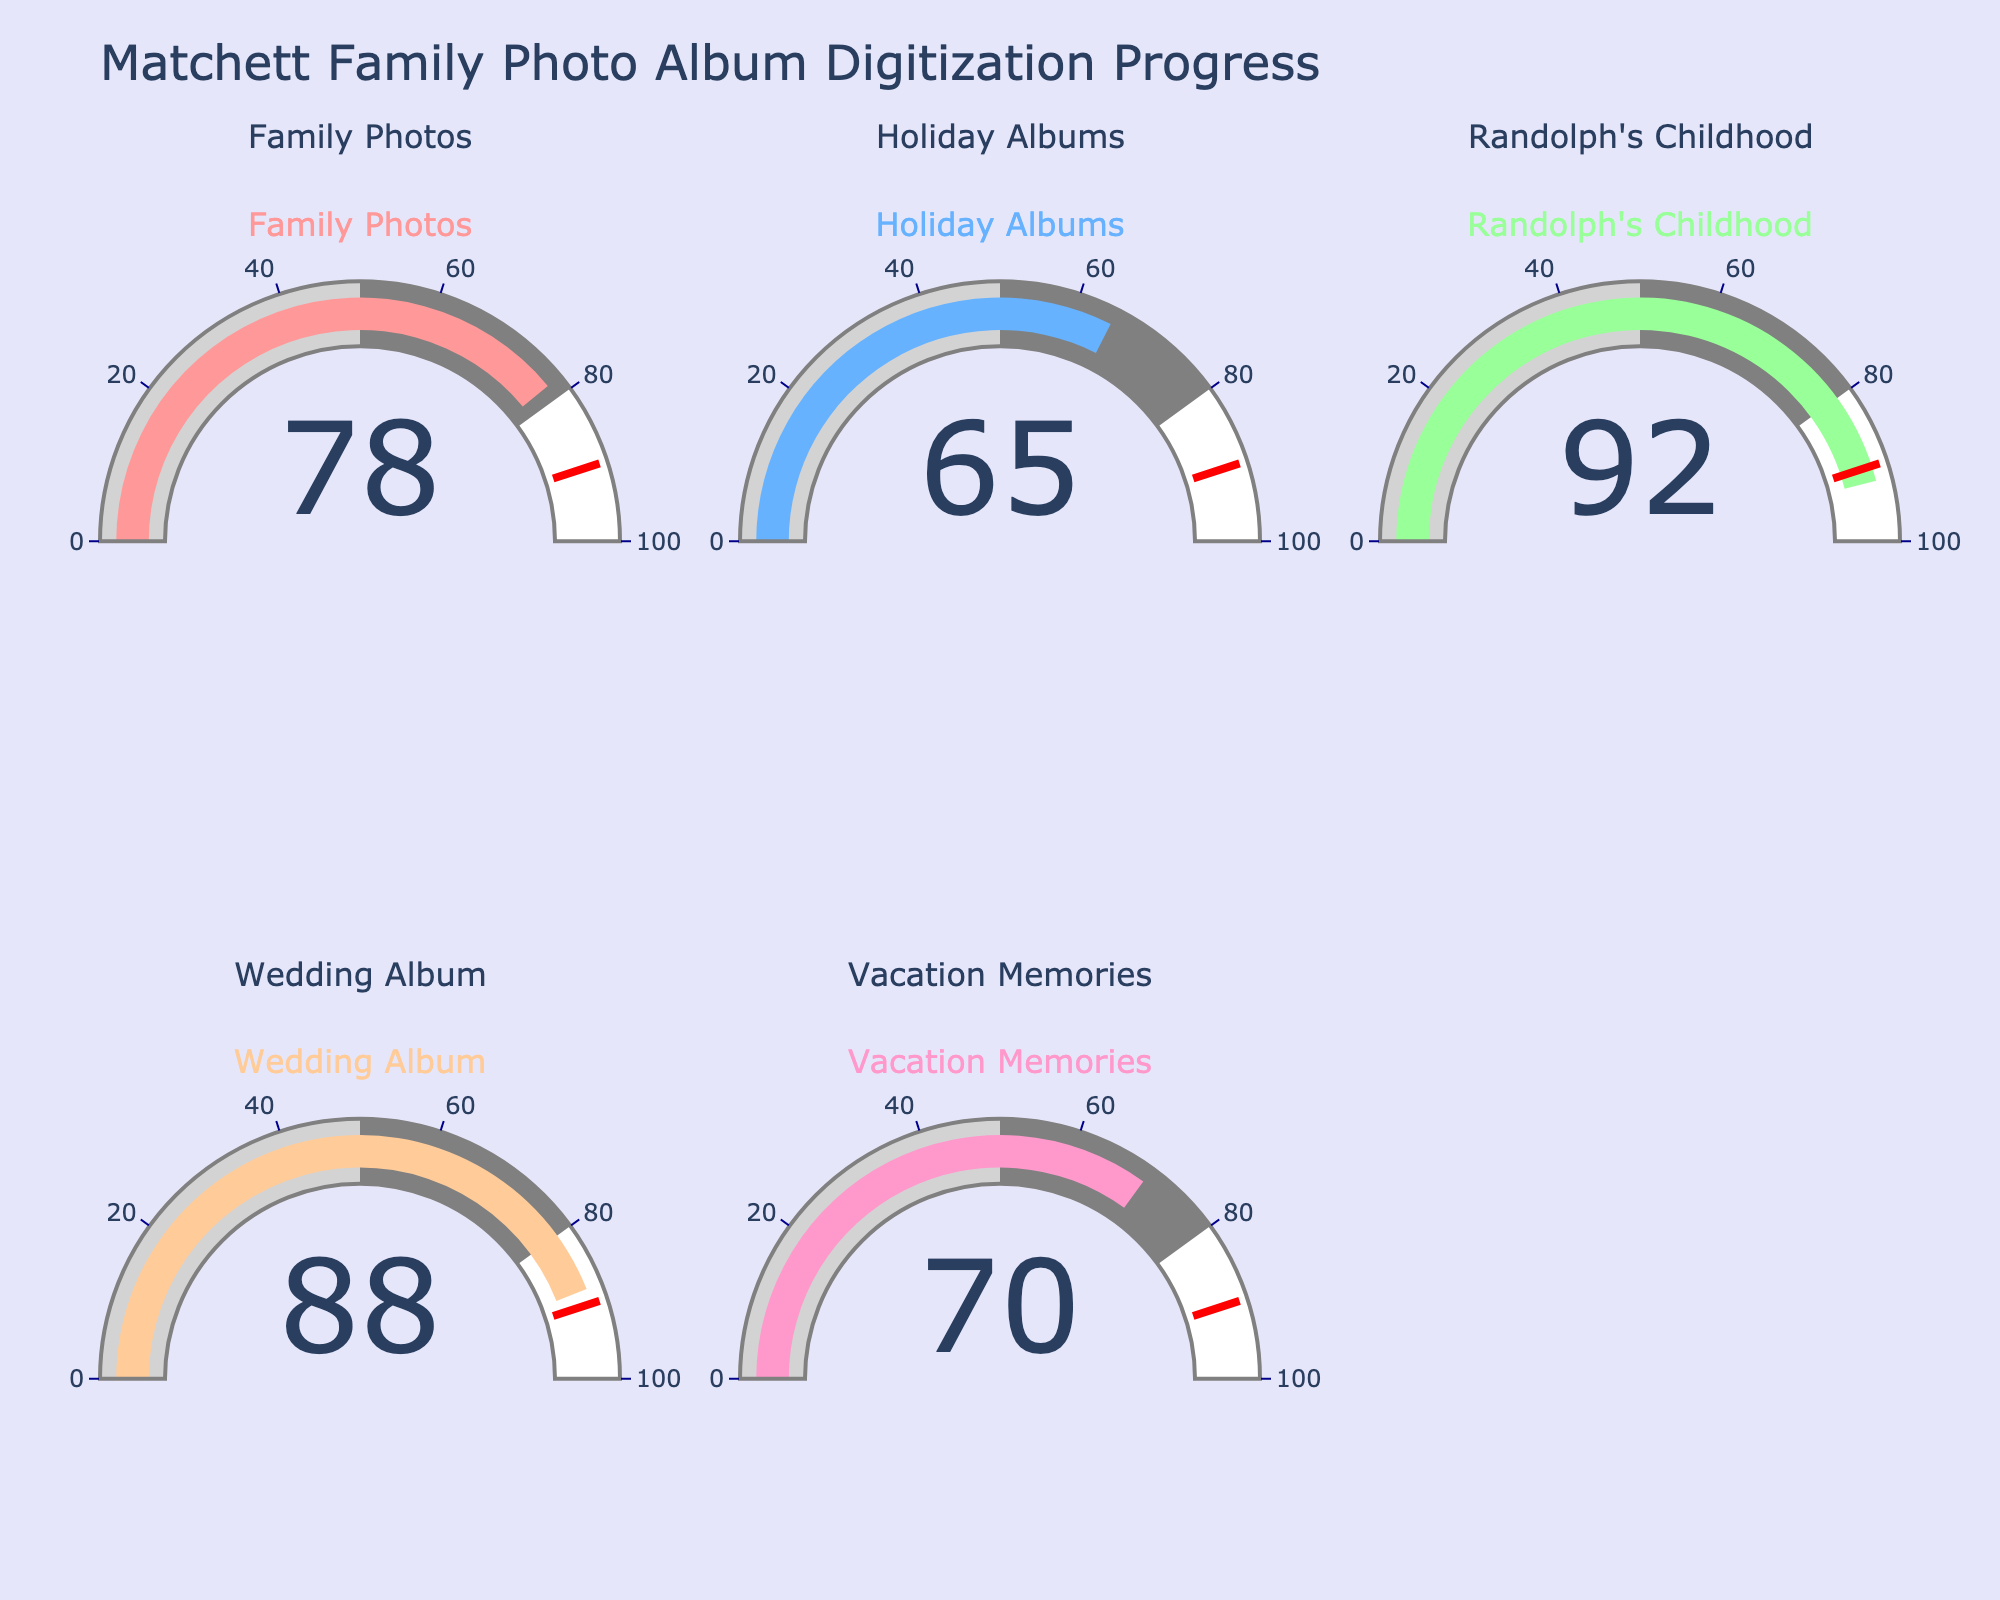what is the title of the chart? The title is displayed at the top of the chart and provides a summary of the content. The title of the chart is given as "Matchett Family Photo Album Digitization Progress".
Answer: Matchett Family Photo Album Digitization Progress which project has the highest completion rate? To find the project with the highest completion rate, examine each gauge for its value. The "Randolph's Childhood" project has the highest completion rate at 92%.
Answer: Randolph's Childhood how many projects are shown in the chart? The chart includes a gauge for each project. By counting the gauges, it can be seen that there are five projects displayed.
Answer: 5 which project has the lowest completion rate? To identify the project with the lowest completion rate, compare the values on each gauge. The "Holiday Albums" project has the lowest completion rate at 65%.
Answer: Holiday Albums what is the combined completion rate of the Wedding Album and Vacation Memories projects? Add the completion rates of the Wedding Album (88) and Vacation Memories (70) projects. 88 + 70 = 158
Answer: 158 which projects have a completion rate of 80% or more? Look for project gauges showing a value of at least 80%. The projects "Randolph's Childhood" (92%) and "Wedding Album" (88%) meet this criterion.
Answer: Randolph's Childhood, Wedding Album which project is closest to reaching the threshold of 90% completion? Compare the completion rates to the threshold line set at 90%. "Wedding Album" is closest, with an 88% completion rate.
Answer: Wedding Album what is the average completion rate of all the projects? Add up all the completion rates and divide by the number of projects. (78 + 65 + 92 + 88 + 70) / 5 = 393 / 5 = 78.6
Answer: 78.6 how many projects have a completion rate between 60% and 80%? Project gauges showing values within this range are "Family Photos" (78%), "Holiday Albums" (65%), and "Vacation Memories" (70%). So, there are three projects.
Answer: 3 